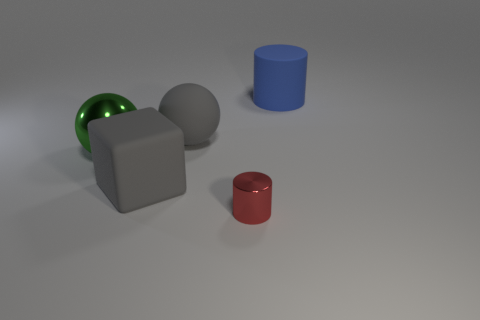There is a shiny thing behind the cylinder that is on the left side of the large matte cylinder; how big is it?
Provide a succinct answer. Large. Are there any other things of the same color as the shiny cylinder?
Make the answer very short. No. Are the cylinder that is behind the gray cube and the thing in front of the large rubber block made of the same material?
Provide a short and direct response. No. There is a thing that is both to the right of the big gray ball and on the left side of the blue thing; what is it made of?
Your answer should be very brief. Metal. Is the shape of the red metal thing the same as the big gray object behind the big green thing?
Keep it short and to the point. No. What is the material of the big gray object that is on the right side of the large gray thing left of the large ball that is behind the big metal object?
Your answer should be very brief. Rubber. How many other things are there of the same size as the red metal cylinder?
Keep it short and to the point. 0. Is the big shiny thing the same color as the large rubber cube?
Your response must be concise. No. There is a red metallic cylinder that is in front of the big matte thing in front of the gray matte sphere; what number of gray cubes are in front of it?
Your answer should be compact. 0. There is a large thing that is behind the large gray thing that is right of the gray cube; what is it made of?
Provide a short and direct response. Rubber. 